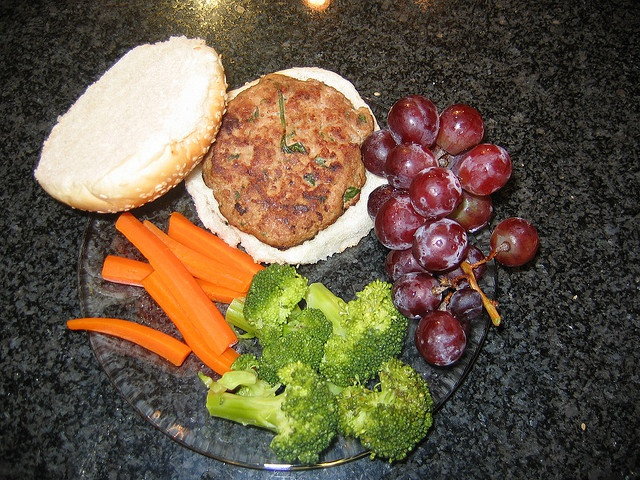Describe the objects in this image and their specific colors. I can see dining table in black, gray, ivory, maroon, and darkgreen tones, sandwich in black, ivory, tan, brown, and salmon tones, broccoli in black, darkgreen, olive, and khaki tones, broccoli in black, darkgreen, and olive tones, and carrot in black, orange, red, and brown tones in this image. 